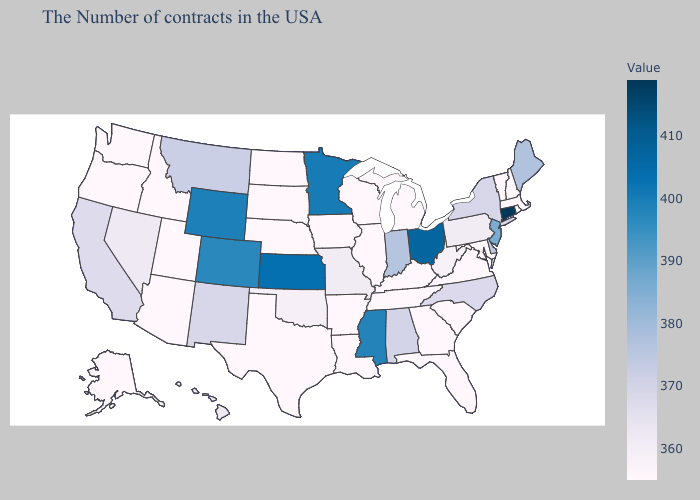Is the legend a continuous bar?
Quick response, please. Yes. Does Missouri have a higher value than New Jersey?
Concise answer only. No. Among the states that border Rhode Island , does Connecticut have the highest value?
Concise answer only. Yes. 